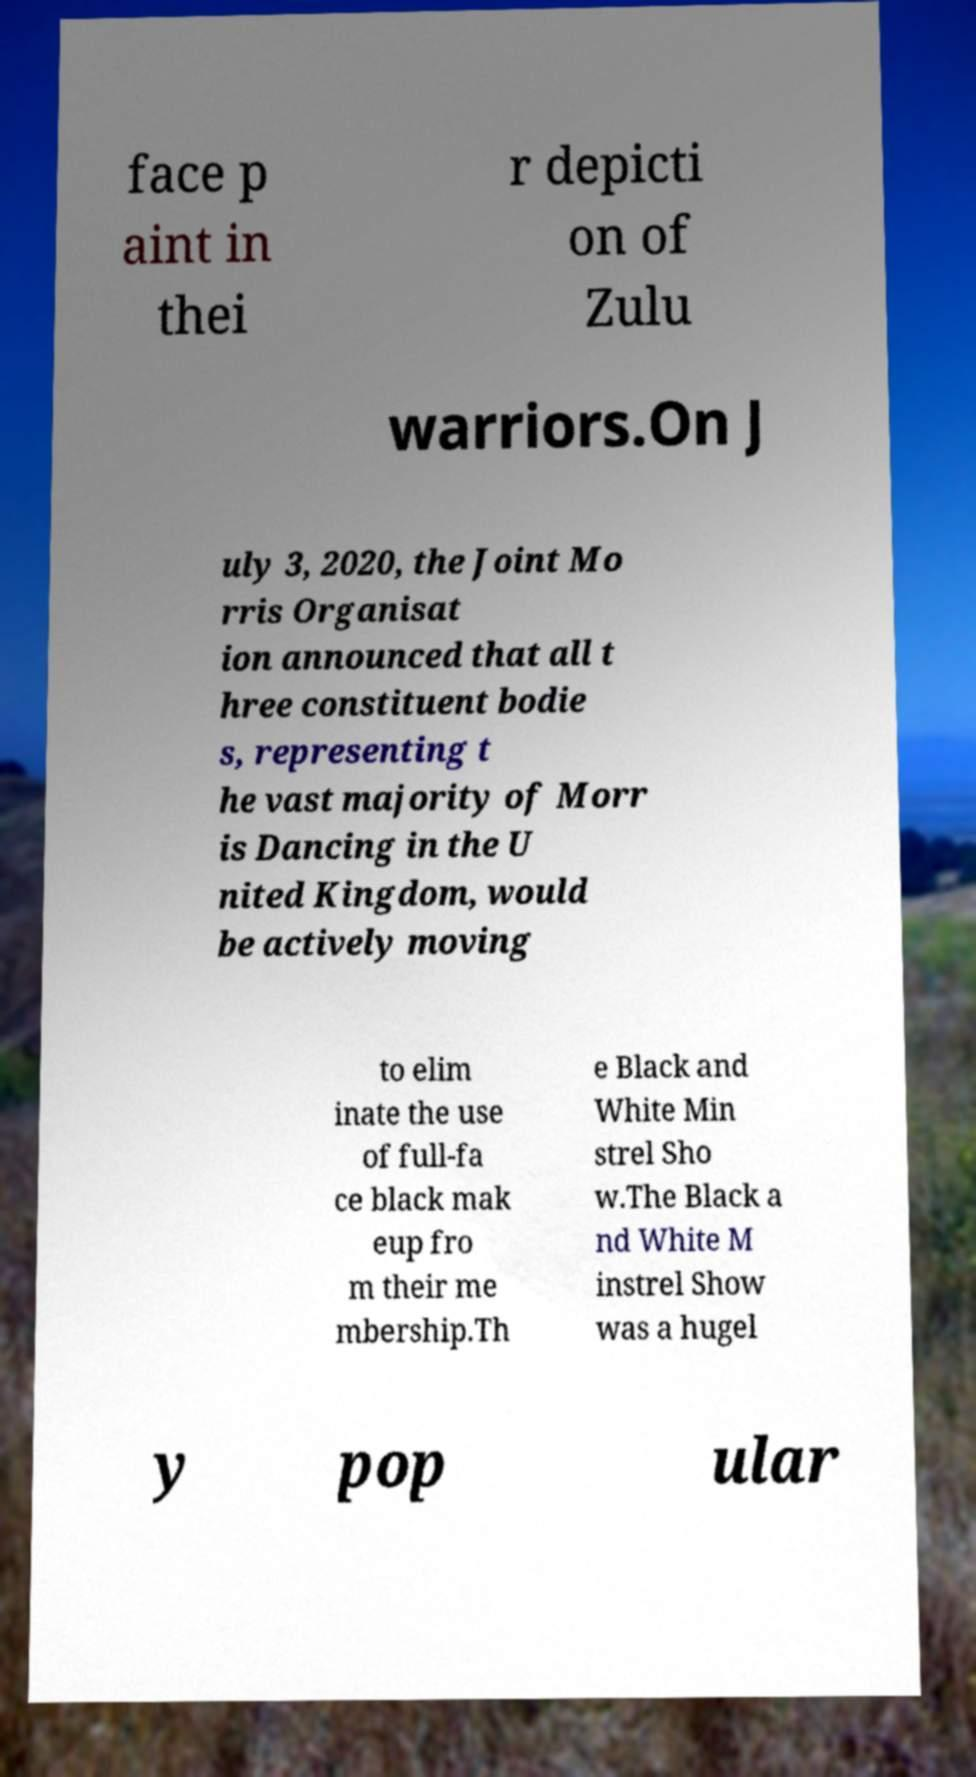What messages or text are displayed in this image? I need them in a readable, typed format. face p aint in thei r depicti on of Zulu warriors.On J uly 3, 2020, the Joint Mo rris Organisat ion announced that all t hree constituent bodie s, representing t he vast majority of Morr is Dancing in the U nited Kingdom, would be actively moving to elim inate the use of full-fa ce black mak eup fro m their me mbership.Th e Black and White Min strel Sho w.The Black a nd White M instrel Show was a hugel y pop ular 